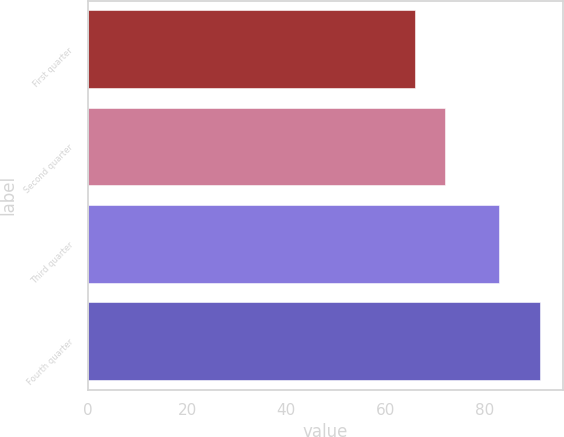Convert chart. <chart><loc_0><loc_0><loc_500><loc_500><bar_chart><fcel>First quarter<fcel>Second quarter<fcel>Third quarter<fcel>Fourth quarter<nl><fcel>66.01<fcel>72.1<fcel>82.93<fcel>91.21<nl></chart> 